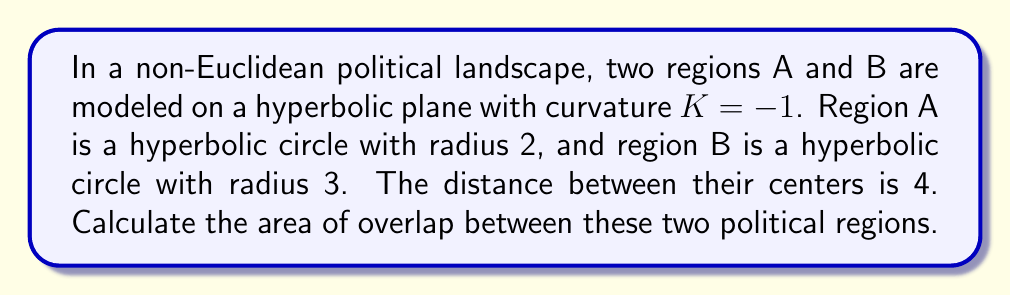What is the answer to this math problem? To solve this problem, we'll follow these steps:

1) First, recall the formula for the area of a hyperbolic circle with radius r:
   $$A = 4\pi \sinh^2(\frac{r}{2})$$

2) Calculate the areas of regions A and B:
   Region A: $$A_A = 4\pi \sinh^2(1) = 4\pi(1.1752)^2 \approx 17.2836$$
   Region B: $$A_B = 4\pi \sinh^2(1.5) = 4\pi(2.1293)^2 \approx 56.7450$$

3) To find the overlap, we need to use the hyperbolic law of cosines:
   $$\cosh(c) = \cosh(a)\cosh(b) - \sinh(a)\sinh(b)\cos(C)$$
   Where c is the distance between centers (4), a and b are the radii (2 and 3), and C is the angle we need to find.

4) Rearranging the formula:
   $$\cos(C) = \frac{\cosh(c) - \cosh(a)\cosh(b)}{\sinh(a)\sinh(b)}$$

5) Plugging in values:
   $$\cos(C) = \frac{\cosh(4) - \cosh(2)\cosh(3)}{\sinh(2)\sinh(3)} \approx 0.2933$$

6) Taking arccos:
   $$C \approx 1.2730 \text{ radians}$$

7) The area of overlap is the sum of two hyperbolic segments. For each segment:
   $$A_{segment} = 2r^2 \arccos(\frac{\cosh(c/2)}{\cosh(r)}) - 2r \sinh(r)\sqrt{1-(\frac{\cosh(c/2)}{\cosh(r)})^2}$$

8) Calculate for both segments and sum:
   Segment A: $$A_{segA} \approx 3.0451$$
   Segment B: $$A_{segB} \approx 8.7034$$
   Total overlap: $$A_{overlap} = A_{segA} + A_{segB} \approx 11.7485$$
Answer: $11.7485$ square units 